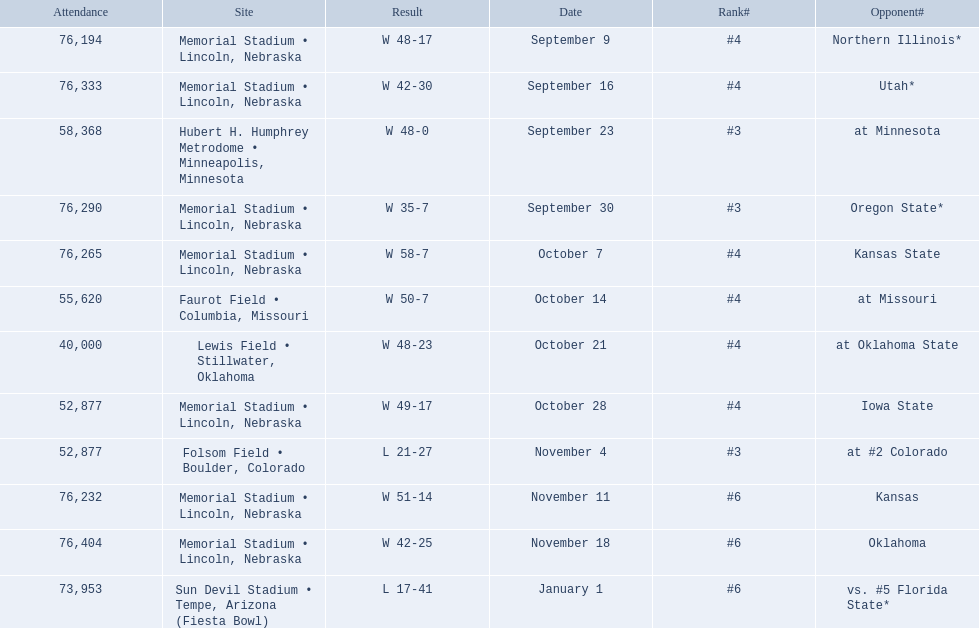Which opponenets did the nebraska cornhuskers score fewer than 40 points against? Oregon State*, at #2 Colorado, vs. #5 Florida State*. Of these games, which ones had an attendance of greater than 70,000? Oregon State*, vs. #5 Florida State*. Which of these opponents did they beat? Oregon State*. How many people were in attendance at that game? 76,290. 